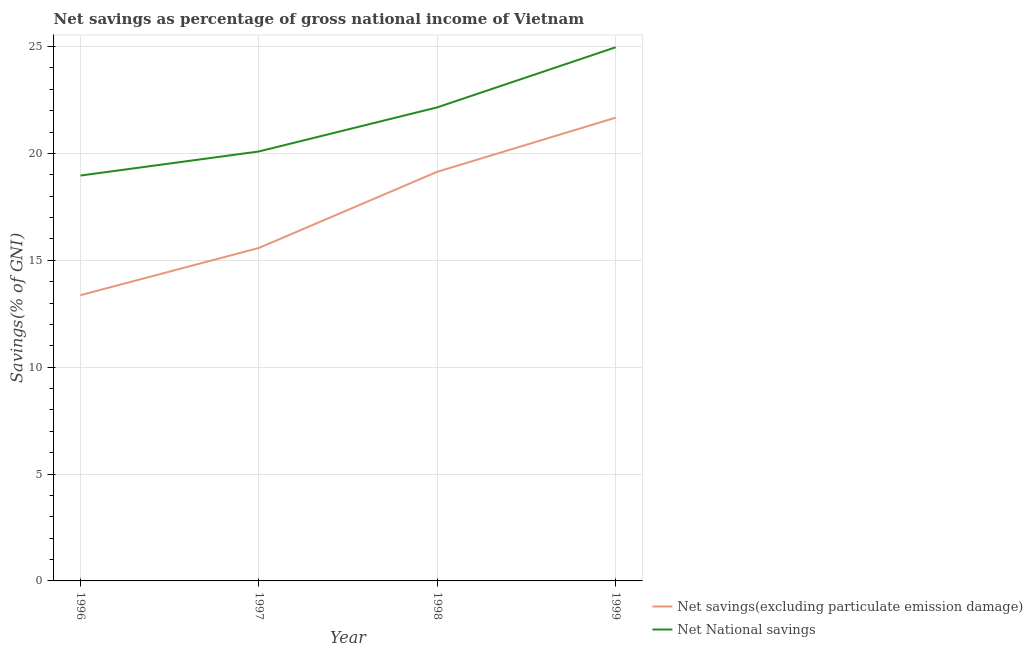How many different coloured lines are there?
Offer a very short reply. 2. Is the number of lines equal to the number of legend labels?
Give a very brief answer. Yes. What is the net national savings in 1997?
Offer a very short reply. 20.09. Across all years, what is the maximum net national savings?
Offer a very short reply. 24.96. Across all years, what is the minimum net national savings?
Offer a terse response. 18.96. What is the total net savings(excluding particulate emission damage) in the graph?
Offer a very short reply. 69.75. What is the difference between the net national savings in 1996 and that in 1998?
Your response must be concise. -3.19. What is the difference between the net savings(excluding particulate emission damage) in 1996 and the net national savings in 1999?
Ensure brevity in your answer.  -11.6. What is the average net national savings per year?
Keep it short and to the point. 21.54. In the year 1997, what is the difference between the net savings(excluding particulate emission damage) and net national savings?
Provide a succinct answer. -4.51. In how many years, is the net national savings greater than 3 %?
Give a very brief answer. 4. What is the ratio of the net national savings in 1996 to that in 1998?
Your answer should be very brief. 0.86. Is the net national savings in 1998 less than that in 1999?
Keep it short and to the point. Yes. Is the difference between the net savings(excluding particulate emission damage) in 1996 and 1998 greater than the difference between the net national savings in 1996 and 1998?
Offer a very short reply. No. What is the difference between the highest and the second highest net savings(excluding particulate emission damage)?
Ensure brevity in your answer.  2.53. What is the difference between the highest and the lowest net savings(excluding particulate emission damage)?
Ensure brevity in your answer.  8.3. In how many years, is the net savings(excluding particulate emission damage) greater than the average net savings(excluding particulate emission damage) taken over all years?
Your answer should be compact. 2. Is the sum of the net national savings in 1997 and 1998 greater than the maximum net savings(excluding particulate emission damage) across all years?
Ensure brevity in your answer.  Yes. Does the net savings(excluding particulate emission damage) monotonically increase over the years?
Make the answer very short. Yes. Is the net national savings strictly less than the net savings(excluding particulate emission damage) over the years?
Provide a short and direct response. No. How many lines are there?
Ensure brevity in your answer.  2. How many years are there in the graph?
Give a very brief answer. 4. Are the values on the major ticks of Y-axis written in scientific E-notation?
Offer a terse response. No. Does the graph contain any zero values?
Provide a succinct answer. No. Where does the legend appear in the graph?
Your answer should be compact. Bottom right. How many legend labels are there?
Give a very brief answer. 2. What is the title of the graph?
Give a very brief answer. Net savings as percentage of gross national income of Vietnam. Does "Subsidies" appear as one of the legend labels in the graph?
Your answer should be very brief. No. What is the label or title of the X-axis?
Make the answer very short. Year. What is the label or title of the Y-axis?
Offer a terse response. Savings(% of GNI). What is the Savings(% of GNI) of Net savings(excluding particulate emission damage) in 1996?
Provide a short and direct response. 13.37. What is the Savings(% of GNI) of Net National savings in 1996?
Make the answer very short. 18.96. What is the Savings(% of GNI) of Net savings(excluding particulate emission damage) in 1997?
Give a very brief answer. 15.58. What is the Savings(% of GNI) in Net National savings in 1997?
Provide a short and direct response. 20.09. What is the Savings(% of GNI) in Net savings(excluding particulate emission damage) in 1998?
Offer a very short reply. 19.14. What is the Savings(% of GNI) in Net National savings in 1998?
Provide a short and direct response. 22.15. What is the Savings(% of GNI) of Net savings(excluding particulate emission damage) in 1999?
Ensure brevity in your answer.  21.67. What is the Savings(% of GNI) in Net National savings in 1999?
Provide a short and direct response. 24.96. Across all years, what is the maximum Savings(% of GNI) in Net savings(excluding particulate emission damage)?
Your answer should be very brief. 21.67. Across all years, what is the maximum Savings(% of GNI) of Net National savings?
Keep it short and to the point. 24.96. Across all years, what is the minimum Savings(% of GNI) of Net savings(excluding particulate emission damage)?
Your answer should be very brief. 13.37. Across all years, what is the minimum Savings(% of GNI) in Net National savings?
Give a very brief answer. 18.96. What is the total Savings(% of GNI) in Net savings(excluding particulate emission damage) in the graph?
Your response must be concise. 69.75. What is the total Savings(% of GNI) of Net National savings in the graph?
Provide a short and direct response. 86.17. What is the difference between the Savings(% of GNI) in Net savings(excluding particulate emission damage) in 1996 and that in 1997?
Your answer should be compact. -2.21. What is the difference between the Savings(% of GNI) of Net National savings in 1996 and that in 1997?
Make the answer very short. -1.13. What is the difference between the Savings(% of GNI) of Net savings(excluding particulate emission damage) in 1996 and that in 1998?
Your answer should be very brief. -5.77. What is the difference between the Savings(% of GNI) of Net National savings in 1996 and that in 1998?
Give a very brief answer. -3.19. What is the difference between the Savings(% of GNI) of Net savings(excluding particulate emission damage) in 1996 and that in 1999?
Your response must be concise. -8.3. What is the difference between the Savings(% of GNI) of Net National savings in 1996 and that in 1999?
Give a very brief answer. -6. What is the difference between the Savings(% of GNI) of Net savings(excluding particulate emission damage) in 1997 and that in 1998?
Offer a very short reply. -3.56. What is the difference between the Savings(% of GNI) of Net National savings in 1997 and that in 1998?
Your answer should be compact. -2.06. What is the difference between the Savings(% of GNI) in Net savings(excluding particulate emission damage) in 1997 and that in 1999?
Provide a succinct answer. -6.09. What is the difference between the Savings(% of GNI) in Net National savings in 1997 and that in 1999?
Offer a very short reply. -4.87. What is the difference between the Savings(% of GNI) in Net savings(excluding particulate emission damage) in 1998 and that in 1999?
Your answer should be very brief. -2.53. What is the difference between the Savings(% of GNI) of Net National savings in 1998 and that in 1999?
Provide a short and direct response. -2.81. What is the difference between the Savings(% of GNI) of Net savings(excluding particulate emission damage) in 1996 and the Savings(% of GNI) of Net National savings in 1997?
Provide a short and direct response. -6.72. What is the difference between the Savings(% of GNI) in Net savings(excluding particulate emission damage) in 1996 and the Savings(% of GNI) in Net National savings in 1998?
Make the answer very short. -8.79. What is the difference between the Savings(% of GNI) in Net savings(excluding particulate emission damage) in 1996 and the Savings(% of GNI) in Net National savings in 1999?
Your answer should be very brief. -11.6. What is the difference between the Savings(% of GNI) of Net savings(excluding particulate emission damage) in 1997 and the Savings(% of GNI) of Net National savings in 1998?
Offer a terse response. -6.58. What is the difference between the Savings(% of GNI) of Net savings(excluding particulate emission damage) in 1997 and the Savings(% of GNI) of Net National savings in 1999?
Provide a short and direct response. -9.39. What is the difference between the Savings(% of GNI) of Net savings(excluding particulate emission damage) in 1998 and the Savings(% of GNI) of Net National savings in 1999?
Your answer should be very brief. -5.82. What is the average Savings(% of GNI) of Net savings(excluding particulate emission damage) per year?
Your answer should be very brief. 17.44. What is the average Savings(% of GNI) in Net National savings per year?
Ensure brevity in your answer.  21.54. In the year 1996, what is the difference between the Savings(% of GNI) in Net savings(excluding particulate emission damage) and Savings(% of GNI) in Net National savings?
Your answer should be very brief. -5.6. In the year 1997, what is the difference between the Savings(% of GNI) of Net savings(excluding particulate emission damage) and Savings(% of GNI) of Net National savings?
Provide a succinct answer. -4.51. In the year 1998, what is the difference between the Savings(% of GNI) of Net savings(excluding particulate emission damage) and Savings(% of GNI) of Net National savings?
Your answer should be compact. -3.01. In the year 1999, what is the difference between the Savings(% of GNI) of Net savings(excluding particulate emission damage) and Savings(% of GNI) of Net National savings?
Make the answer very short. -3.29. What is the ratio of the Savings(% of GNI) in Net savings(excluding particulate emission damage) in 1996 to that in 1997?
Offer a very short reply. 0.86. What is the ratio of the Savings(% of GNI) of Net National savings in 1996 to that in 1997?
Your answer should be compact. 0.94. What is the ratio of the Savings(% of GNI) of Net savings(excluding particulate emission damage) in 1996 to that in 1998?
Keep it short and to the point. 0.7. What is the ratio of the Savings(% of GNI) of Net National savings in 1996 to that in 1998?
Make the answer very short. 0.86. What is the ratio of the Savings(% of GNI) of Net savings(excluding particulate emission damage) in 1996 to that in 1999?
Your answer should be very brief. 0.62. What is the ratio of the Savings(% of GNI) in Net National savings in 1996 to that in 1999?
Your answer should be compact. 0.76. What is the ratio of the Savings(% of GNI) in Net savings(excluding particulate emission damage) in 1997 to that in 1998?
Your answer should be compact. 0.81. What is the ratio of the Savings(% of GNI) of Net National savings in 1997 to that in 1998?
Your answer should be very brief. 0.91. What is the ratio of the Savings(% of GNI) in Net savings(excluding particulate emission damage) in 1997 to that in 1999?
Ensure brevity in your answer.  0.72. What is the ratio of the Savings(% of GNI) in Net National savings in 1997 to that in 1999?
Give a very brief answer. 0.8. What is the ratio of the Savings(% of GNI) in Net savings(excluding particulate emission damage) in 1998 to that in 1999?
Ensure brevity in your answer.  0.88. What is the ratio of the Savings(% of GNI) of Net National savings in 1998 to that in 1999?
Make the answer very short. 0.89. What is the difference between the highest and the second highest Savings(% of GNI) of Net savings(excluding particulate emission damage)?
Offer a very short reply. 2.53. What is the difference between the highest and the second highest Savings(% of GNI) in Net National savings?
Provide a short and direct response. 2.81. What is the difference between the highest and the lowest Savings(% of GNI) of Net savings(excluding particulate emission damage)?
Offer a very short reply. 8.3. What is the difference between the highest and the lowest Savings(% of GNI) of Net National savings?
Ensure brevity in your answer.  6. 